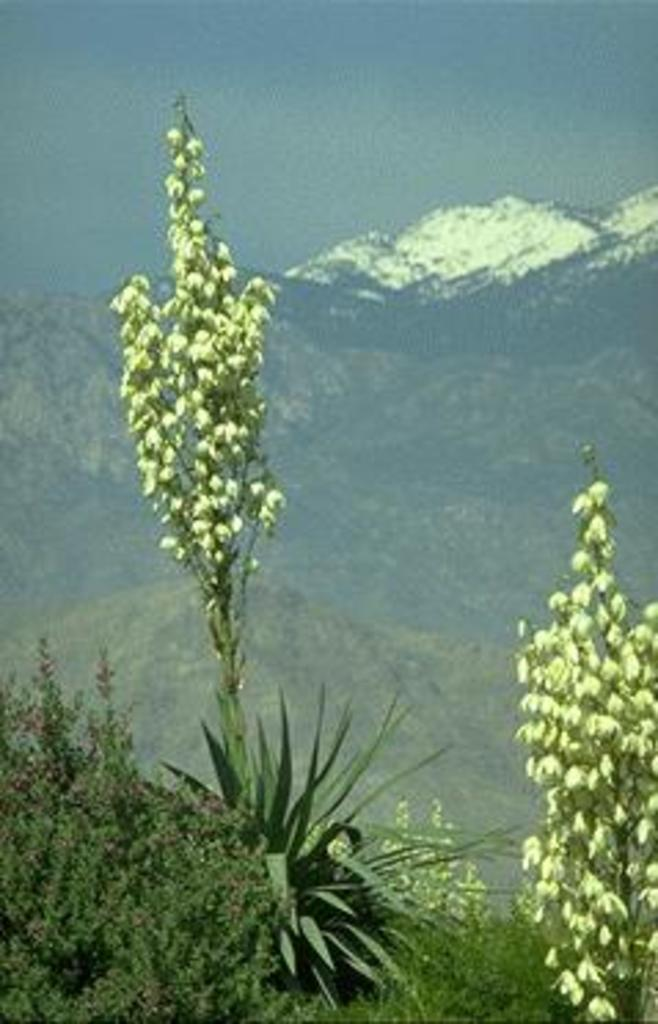What is located in the foreground of the image? There are plants in the foreground of the image. What can be seen in the background of the image? There are mountains in the background of the image. Where is the pail located in the image? There is no pail present in the image. What type of building can be seen in the image? There is no building present in the image; it features plants in the foreground and mountains in the background. 